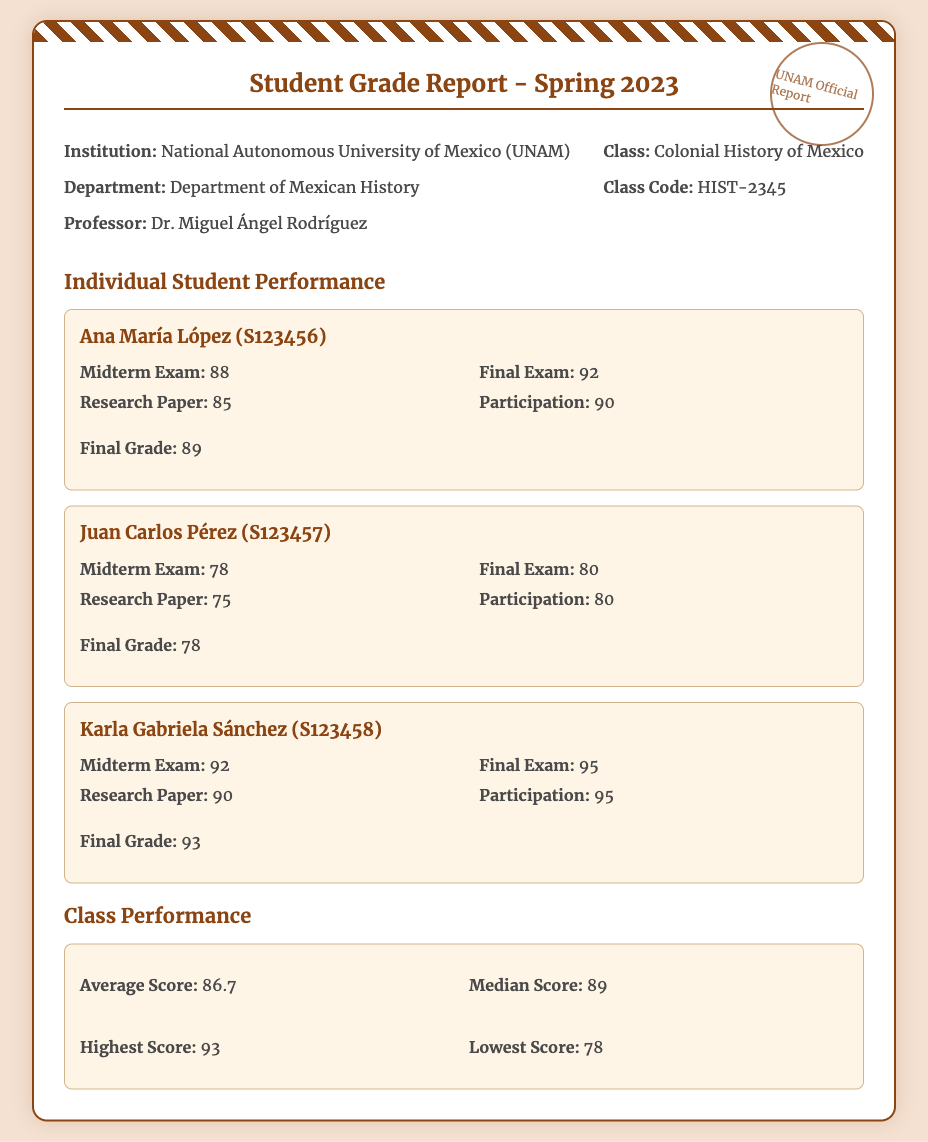What is the title of the report? The title of the report is mentioned at the top of the document, indicating the subject matter.
Answer: Student Grade Report - Spring 2023 Who is the professor? The document includes information about the professor responsible for the course.
Answer: Dr. Miguel Ángel Rodríguez What is Juan Carlos Pérez's final grade? The final grade for each student is listed in their individual performance section.
Answer: 78 What was the highest score in the class? The class performance section summarizes various statistics, including the highest score.
Answer: 93 What is the average score for the class? The average score is provided in the class performance section and reflects overall student performance.
Answer: 86.7 What are the subjects of Ana María López's scores? The individual student performance lists specific assessments that contributed to the final grade.
Answer: Midterm Exam, Final Exam, Research Paper, Participation What class is this report about? This information helps understand the context of the student grades presented in the report.
Answer: Colonial History of Mexico What is the lowest score recorded? The lowest score is an important statistic included in the class performance section.
Answer: 78 How many students' performances are detailed in the report? The document provides a specific number of student performance summaries which inform about participation levels.
Answer: 3 